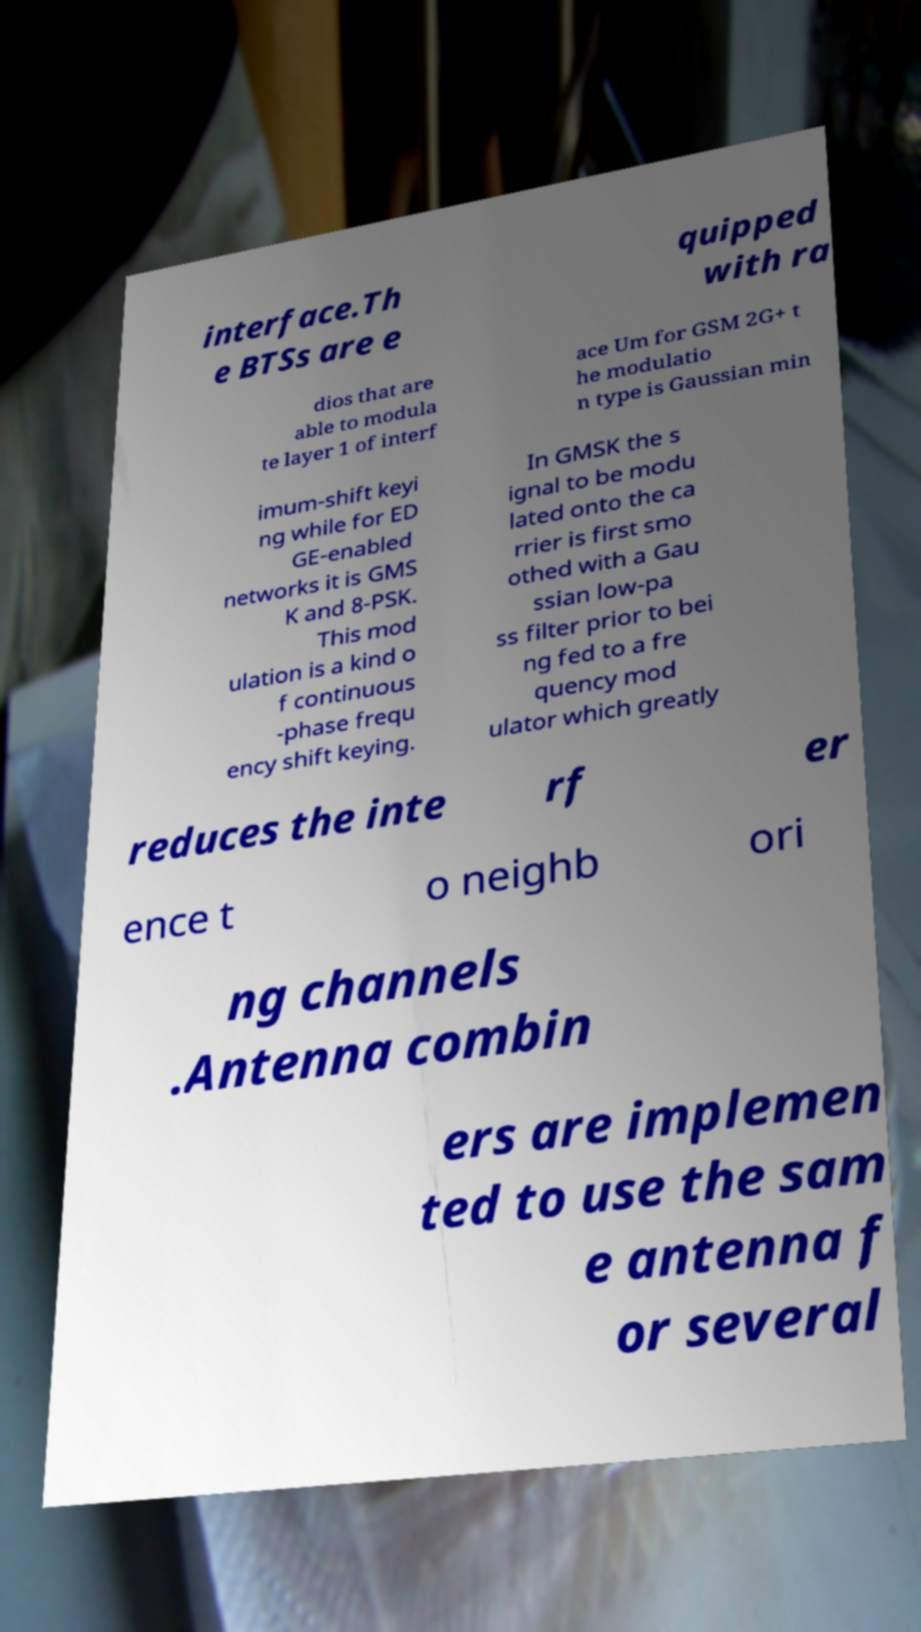I need the written content from this picture converted into text. Can you do that? interface.Th e BTSs are e quipped with ra dios that are able to modula te layer 1 of interf ace Um for GSM 2G+ t he modulatio n type is Gaussian min imum-shift keyi ng while for ED GE-enabled networks it is GMS K and 8-PSK. This mod ulation is a kind o f continuous -phase frequ ency shift keying. In GMSK the s ignal to be modu lated onto the ca rrier is first smo othed with a Gau ssian low-pa ss filter prior to bei ng fed to a fre quency mod ulator which greatly reduces the inte rf er ence t o neighb ori ng channels .Antenna combin ers are implemen ted to use the sam e antenna f or several 